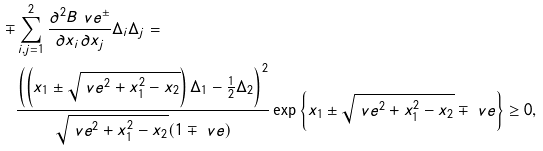Convert formula to latex. <formula><loc_0><loc_0><loc_500><loc_500>\mp & \sum _ { i , j = 1 } ^ { 2 } \frac { \partial ^ { 2 } B _ { \ } v e ^ { \pm } } { \partial x _ { i } \partial x _ { j } } \Delta _ { i } \Delta _ { j } = & \\ & \frac { \left ( \left ( x _ { 1 } \pm \sqrt { \ v e ^ { 2 } + x _ { 1 } ^ { 2 } - x _ { 2 } } \right ) \Delta _ { 1 } - \frac { 1 } { 2 } \Delta _ { 2 } \right ) ^ { 2 } } { \sqrt { \ v e ^ { 2 } + x _ { 1 } ^ { 2 } - x _ { 2 } } ( 1 \mp \ v e ) } \exp \left \{ x _ { 1 } \pm \sqrt { \ v e ^ { 2 } + x _ { 1 } ^ { 2 } - x _ { 2 } } \mp \ v e \right \} \geq 0 ,</formula> 